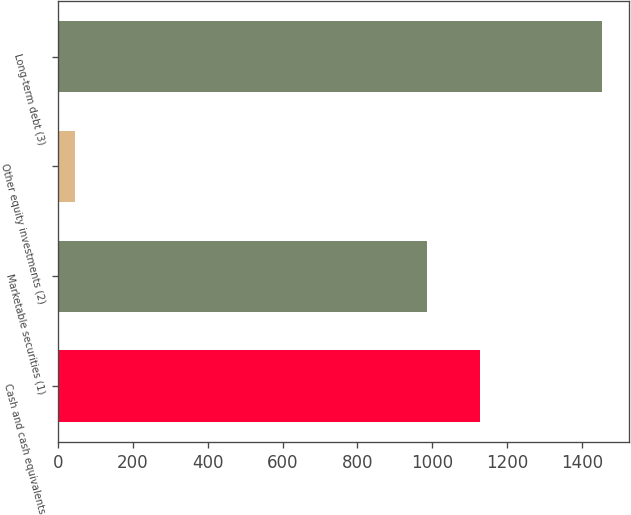Convert chart to OTSL. <chart><loc_0><loc_0><loc_500><loc_500><bar_chart><fcel>Cash and cash equivalents<fcel>Marketable securities (1)<fcel>Other equity investments (2)<fcel>Long-term debt (3)<nl><fcel>1127.9<fcel>987<fcel>45<fcel>1454<nl></chart> 